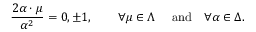Convert formula to latex. <formula><loc_0><loc_0><loc_500><loc_500>{ \frac { 2 \alpha \cdot \mu } { \alpha ^ { 2 } } } = 0 , \pm 1 , \quad \forall \mu \in \Lambda \quad \ a n d \quad \forall \alpha \in \Delta .</formula> 